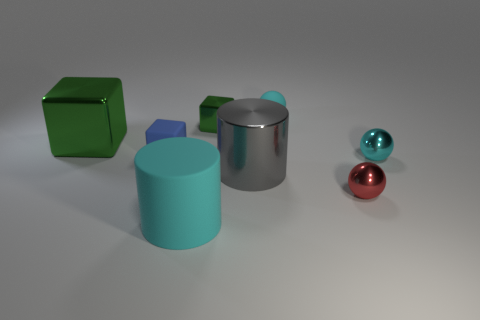Subtract 1 blocks. How many blocks are left? 2 Subtract all large blocks. How many blocks are left? 2 Add 1 big cyan cylinders. How many objects exist? 9 Subtract all spheres. How many objects are left? 5 Add 6 big cylinders. How many big cylinders are left? 8 Add 7 tiny rubber spheres. How many tiny rubber spheres exist? 8 Subtract 0 gray blocks. How many objects are left? 8 Subtract all purple matte blocks. Subtract all cubes. How many objects are left? 5 